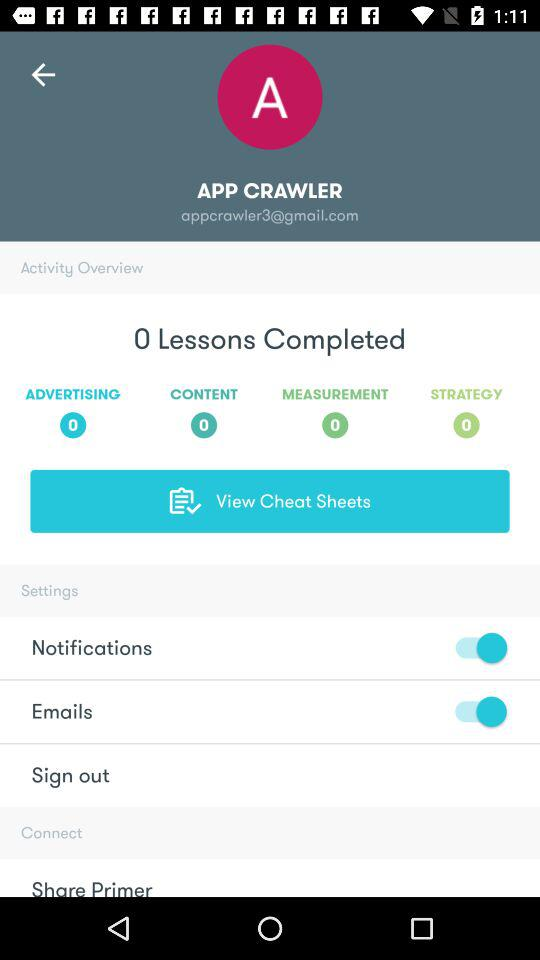How many lessons are completed? The completed lessons are 0. 